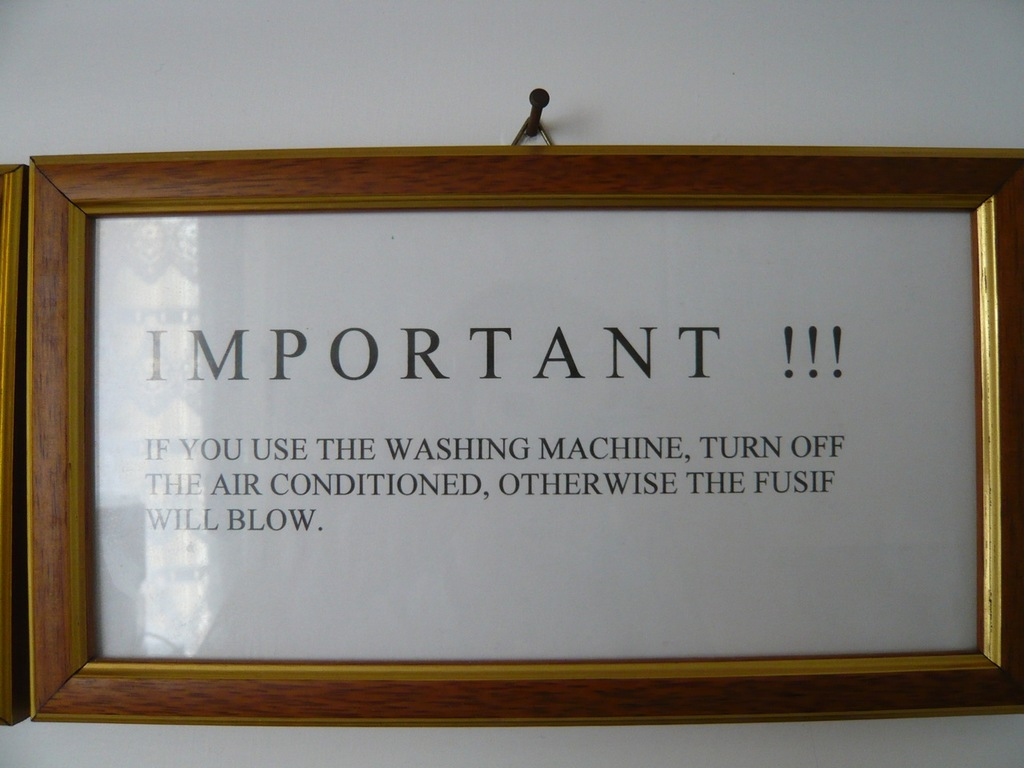What do you see happening in this image? The image shows a warning notice framed and hanging on a white wall. It reads: 'IMPORTANT !!! IF YOU USE THE WASHING MACHINE, TURN OFF THE AIR CONDITIONED, OTHERWISE THE FUSE WILL BLOW.' This warning suggests there could be an electrical overload if both appliances are used simultaneously, highlighting a potential safety issue. The notice serves as a practical reminder to prevent electrical mishaps in settings where the electrical system might not support high concurrent loads. 